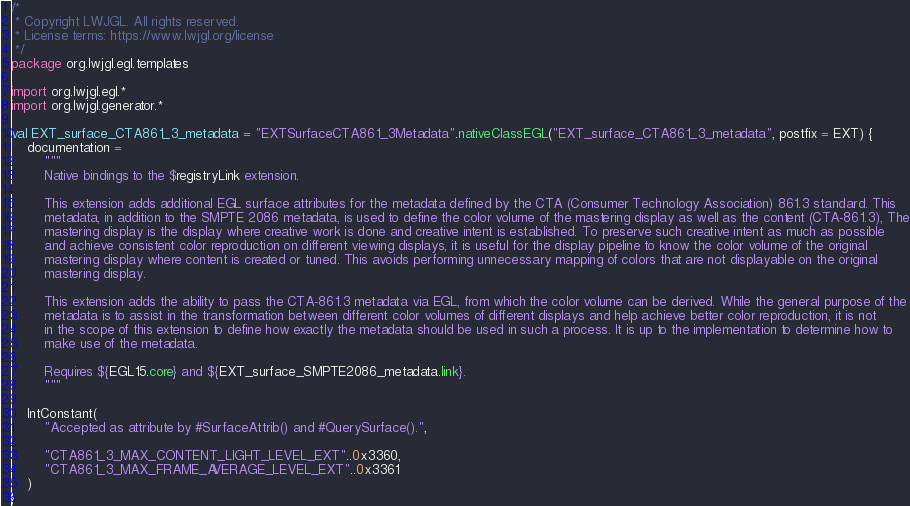Convert code to text. <code><loc_0><loc_0><loc_500><loc_500><_Kotlin_>/*
 * Copyright LWJGL. All rights reserved.
 * License terms: https://www.lwjgl.org/license
 */
package org.lwjgl.egl.templates

import org.lwjgl.egl.*
import org.lwjgl.generator.*

val EXT_surface_CTA861_3_metadata = "EXTSurfaceCTA861_3Metadata".nativeClassEGL("EXT_surface_CTA861_3_metadata", postfix = EXT) {
    documentation =
        """
        Native bindings to the $registryLink extension.

        This extension adds additional EGL surface attributes for the metadata defined by the CTA (Consumer Technology Association) 861.3 standard. This
        metadata, in addition to the SMPTE 2086 metadata, is used to define the color volume of the mastering display as well as the content (CTA-861.3), The
        mastering display is the display where creative work is done and creative intent is established. To preserve such creative intent as much as possible
        and achieve consistent color reproduction on different viewing displays, it is useful for the display pipeline to know the color volume of the original
        mastering display where content is created or tuned. This avoids performing unnecessary mapping of colors that are not displayable on the original
        mastering display.

        This extension adds the ability to pass the CTA-861.3 metadata via EGL, from which the color volume can be derived. While the general purpose of the
        metadata is to assist in the transformation between different color volumes of different displays and help achieve better color reproduction, it is not
        in the scope of this extension to define how exactly the metadata should be used in such a process. It is up to the implementation to determine how to
        make use of the metadata.

        Requires ${EGL15.core} and ${EXT_surface_SMPTE2086_metadata.link}.
        """

    IntConstant(
        "Accepted as attribute by #SurfaceAttrib() and #QuerySurface().",

        "CTA861_3_MAX_CONTENT_LIGHT_LEVEL_EXT"..0x3360,
        "CTA861_3_MAX_FRAME_AVERAGE_LEVEL_EXT"..0x3361
    )
}</code> 